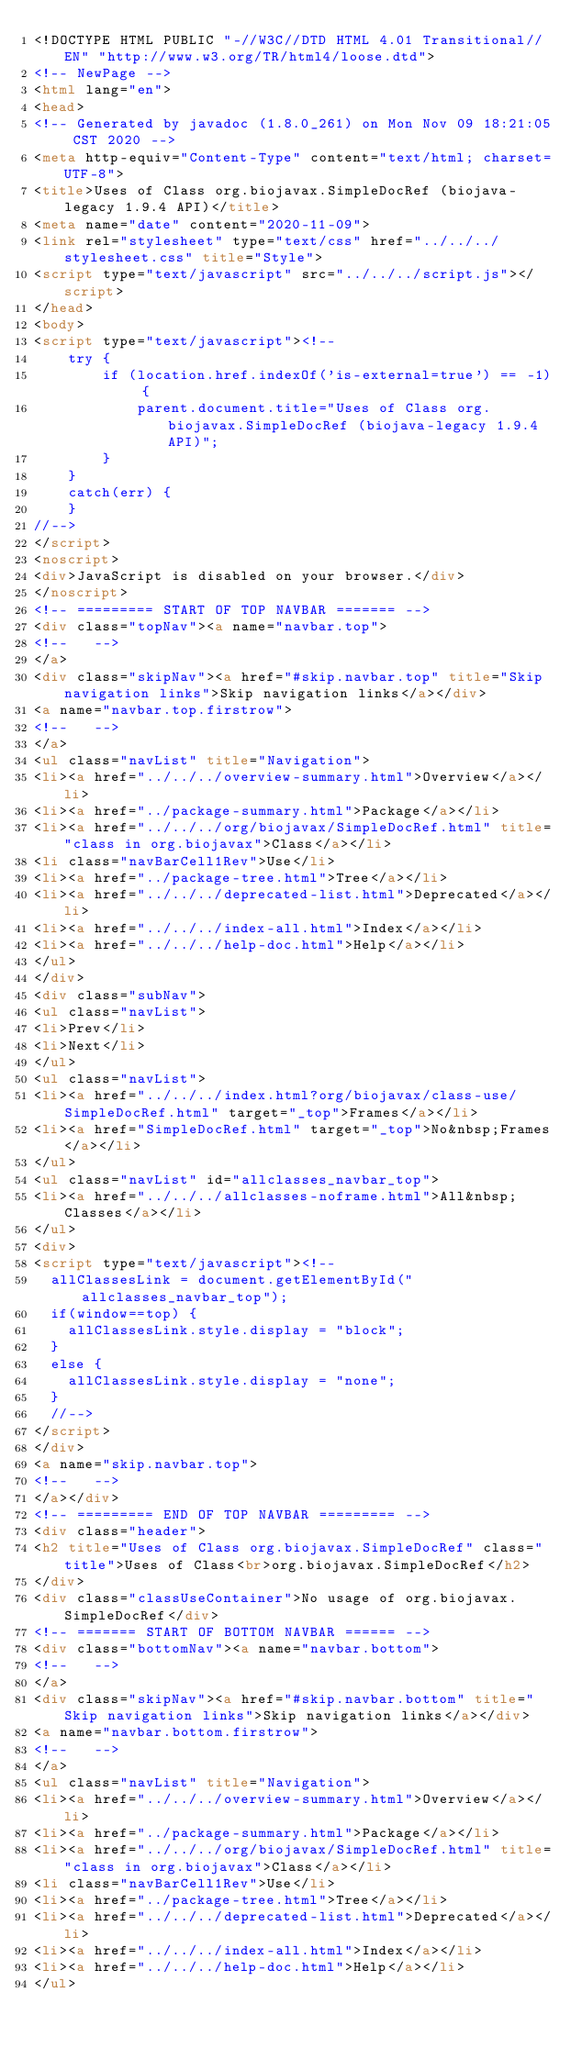Convert code to text. <code><loc_0><loc_0><loc_500><loc_500><_HTML_><!DOCTYPE HTML PUBLIC "-//W3C//DTD HTML 4.01 Transitional//EN" "http://www.w3.org/TR/html4/loose.dtd">
<!-- NewPage -->
<html lang="en">
<head>
<!-- Generated by javadoc (1.8.0_261) on Mon Nov 09 18:21:05 CST 2020 -->
<meta http-equiv="Content-Type" content="text/html; charset=UTF-8">
<title>Uses of Class org.biojavax.SimpleDocRef (biojava-legacy 1.9.4 API)</title>
<meta name="date" content="2020-11-09">
<link rel="stylesheet" type="text/css" href="../../../stylesheet.css" title="Style">
<script type="text/javascript" src="../../../script.js"></script>
</head>
<body>
<script type="text/javascript"><!--
    try {
        if (location.href.indexOf('is-external=true') == -1) {
            parent.document.title="Uses of Class org.biojavax.SimpleDocRef (biojava-legacy 1.9.4 API)";
        }
    }
    catch(err) {
    }
//-->
</script>
<noscript>
<div>JavaScript is disabled on your browser.</div>
</noscript>
<!-- ========= START OF TOP NAVBAR ======= -->
<div class="topNav"><a name="navbar.top">
<!--   -->
</a>
<div class="skipNav"><a href="#skip.navbar.top" title="Skip navigation links">Skip navigation links</a></div>
<a name="navbar.top.firstrow">
<!--   -->
</a>
<ul class="navList" title="Navigation">
<li><a href="../../../overview-summary.html">Overview</a></li>
<li><a href="../package-summary.html">Package</a></li>
<li><a href="../../../org/biojavax/SimpleDocRef.html" title="class in org.biojavax">Class</a></li>
<li class="navBarCell1Rev">Use</li>
<li><a href="../package-tree.html">Tree</a></li>
<li><a href="../../../deprecated-list.html">Deprecated</a></li>
<li><a href="../../../index-all.html">Index</a></li>
<li><a href="../../../help-doc.html">Help</a></li>
</ul>
</div>
<div class="subNav">
<ul class="navList">
<li>Prev</li>
<li>Next</li>
</ul>
<ul class="navList">
<li><a href="../../../index.html?org/biojavax/class-use/SimpleDocRef.html" target="_top">Frames</a></li>
<li><a href="SimpleDocRef.html" target="_top">No&nbsp;Frames</a></li>
</ul>
<ul class="navList" id="allclasses_navbar_top">
<li><a href="../../../allclasses-noframe.html">All&nbsp;Classes</a></li>
</ul>
<div>
<script type="text/javascript"><!--
  allClassesLink = document.getElementById("allclasses_navbar_top");
  if(window==top) {
    allClassesLink.style.display = "block";
  }
  else {
    allClassesLink.style.display = "none";
  }
  //-->
</script>
</div>
<a name="skip.navbar.top">
<!--   -->
</a></div>
<!-- ========= END OF TOP NAVBAR ========= -->
<div class="header">
<h2 title="Uses of Class org.biojavax.SimpleDocRef" class="title">Uses of Class<br>org.biojavax.SimpleDocRef</h2>
</div>
<div class="classUseContainer">No usage of org.biojavax.SimpleDocRef</div>
<!-- ======= START OF BOTTOM NAVBAR ====== -->
<div class="bottomNav"><a name="navbar.bottom">
<!--   -->
</a>
<div class="skipNav"><a href="#skip.navbar.bottom" title="Skip navigation links">Skip navigation links</a></div>
<a name="navbar.bottom.firstrow">
<!--   -->
</a>
<ul class="navList" title="Navigation">
<li><a href="../../../overview-summary.html">Overview</a></li>
<li><a href="../package-summary.html">Package</a></li>
<li><a href="../../../org/biojavax/SimpleDocRef.html" title="class in org.biojavax">Class</a></li>
<li class="navBarCell1Rev">Use</li>
<li><a href="../package-tree.html">Tree</a></li>
<li><a href="../../../deprecated-list.html">Deprecated</a></li>
<li><a href="../../../index-all.html">Index</a></li>
<li><a href="../../../help-doc.html">Help</a></li>
</ul></code> 